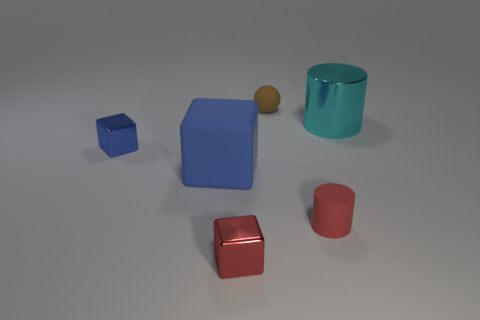Is the material of the red cylinder the same as the large thing that is to the left of the tiny brown ball?
Make the answer very short. Yes. What number of other objects are there of the same shape as the cyan thing?
Provide a succinct answer. 1. There is a tiny sphere; is it the same color as the small block that is in front of the matte cube?
Offer a very short reply. No. Is there any other thing that has the same material as the cyan cylinder?
Provide a succinct answer. Yes. There is a metal thing to the right of the tiny rubber thing that is in front of the tiny brown ball; what is its shape?
Provide a succinct answer. Cylinder. There is a metal block that is the same color as the big rubber thing; what is its size?
Offer a very short reply. Small. There is a thing that is on the left side of the large rubber thing; does it have the same shape as the large matte thing?
Your response must be concise. Yes. Is the number of rubber spheres left of the brown ball greater than the number of small rubber spheres that are in front of the cyan cylinder?
Your answer should be very brief. No. There is a tiny matte thing that is behind the cyan object; what number of big things are to the left of it?
Your answer should be compact. 1. What is the material of the tiny object that is the same color as the big block?
Offer a very short reply. Metal. 